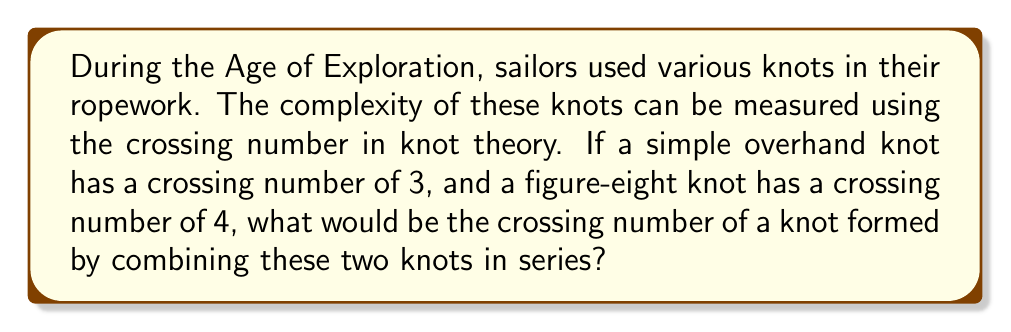Help me with this question. Let's approach this step-by-step:

1) In knot theory, the crossing number of a knot is the smallest number of crossings in any diagram of the knot.

2) We are given that:
   - An overhand knot has a crossing number of 3
   - A figure-eight knot has a crossing number of 4

3) When we combine knots in series, we are essentially creating a composite knot.

4) A key theorem in knot theory states that for composite knots:

   $$c(K_1 \# K_2) = c(K_1) + c(K_2)$$

   Where $c(K)$ denotes the crossing number of knot $K$, and $\#$ denotes the knot sum operation.

5) In this case, we have:
   
   $$c(\text{Composite}) = c(\text{Overhand}) + c(\text{Figure-eight})$$

6) Substituting the known values:

   $$c(\text{Composite}) = 3 + 4 = 7$$

Therefore, the crossing number of the composite knot formed by combining an overhand knot and a figure-eight knot in series is 7.
Answer: 7 